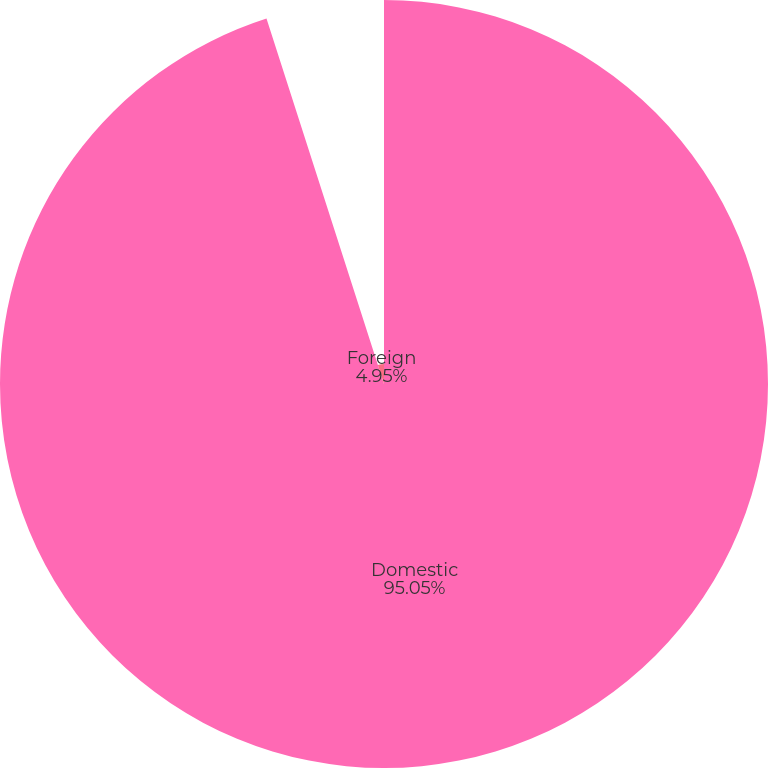Convert chart to OTSL. <chart><loc_0><loc_0><loc_500><loc_500><pie_chart><fcel>Domestic<fcel>Foreign<nl><fcel>95.05%<fcel>4.95%<nl></chart> 